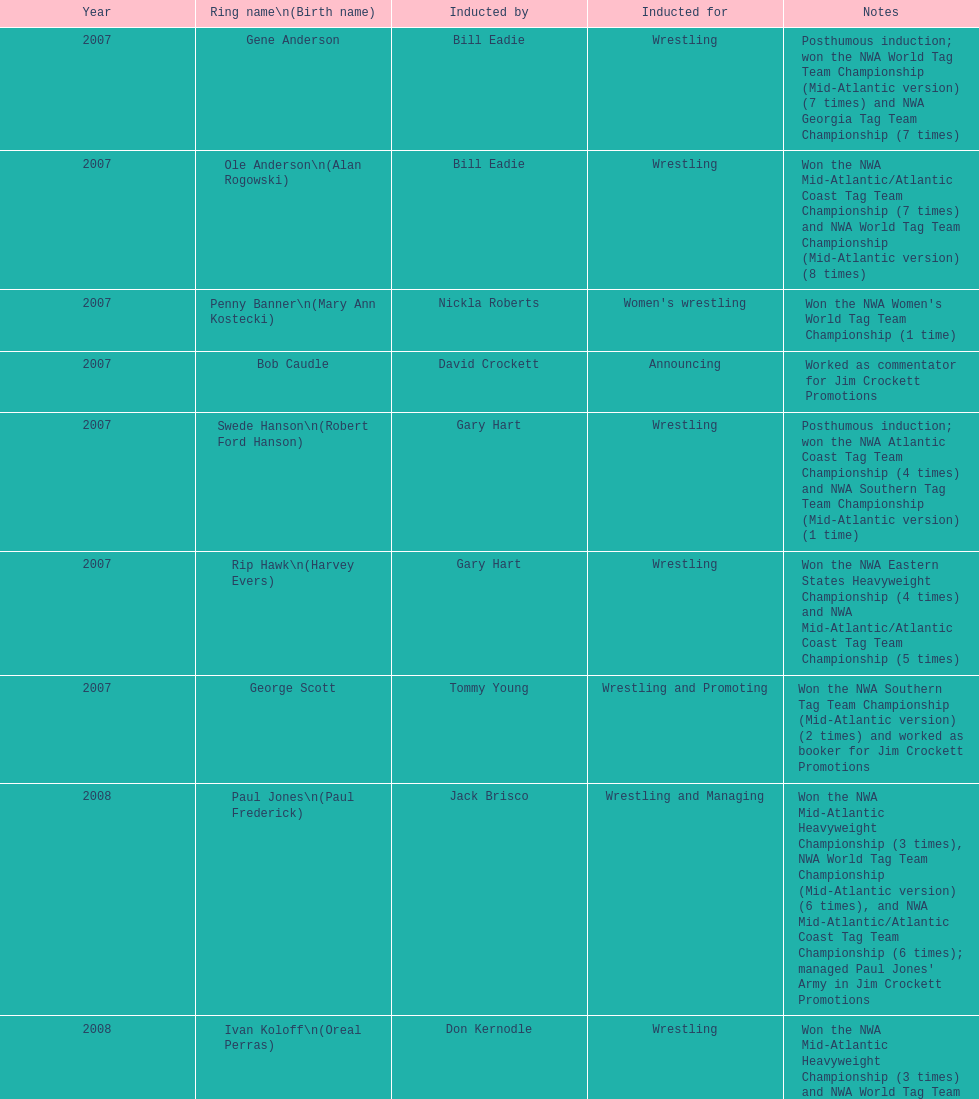After royal, who was the next inductee? Lance Russell. 